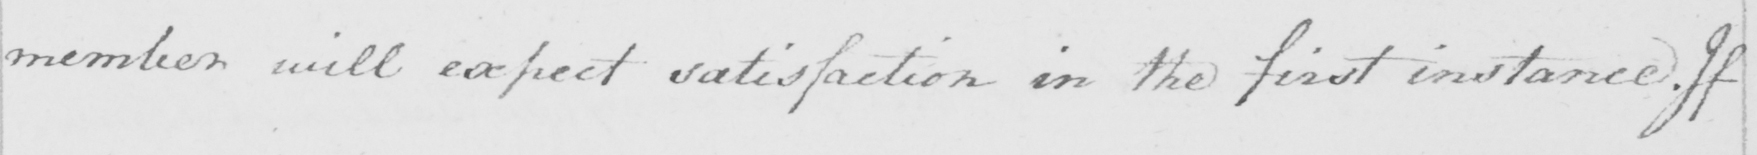Can you read and transcribe this handwriting? member will expect satisfaction in the first instance. If 